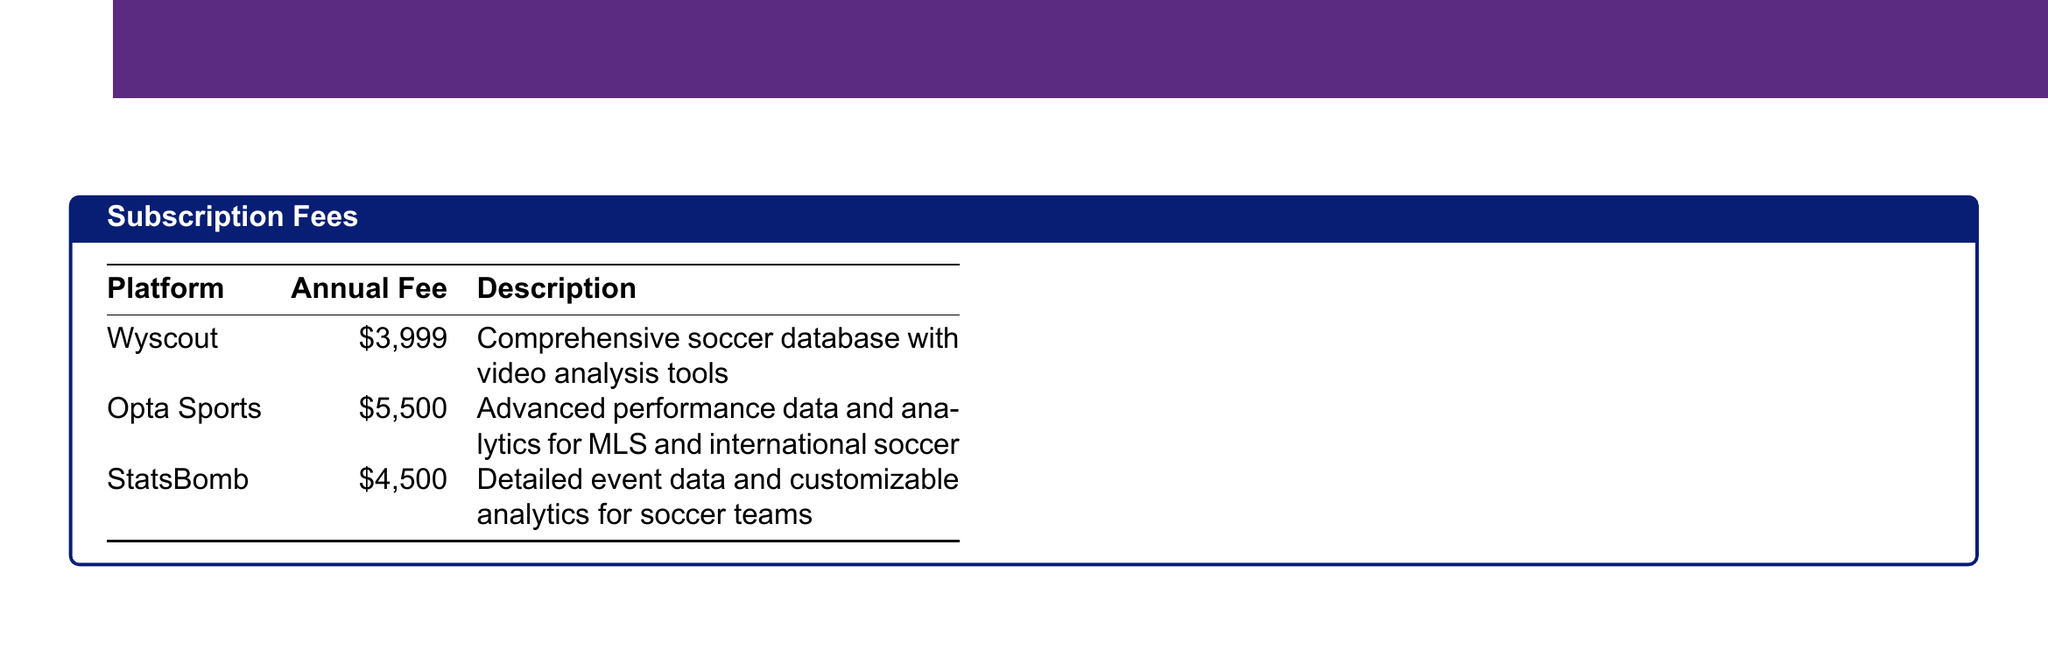What is the annual fee for Wyscout? The annual fee for Wyscout is specified in the document as $3,999.
Answer: $3,999 What is the total cost for subscription fees? The total cost for subscription fees is clearly laid out in the document as $13,999.
Answer: $13,999 How much does the online course cost? The document lists the cost of the online course as $499.
Answer: $499 What is the fee for custom Rapids reports? The fee for custom Rapids reports is mentioned as $250 per month in the document.
Answer: $250/month What platform has the highest annual fee? By comparing the annual fees listed, Opta Sports has the highest fee at $5,500.
Answer: Opta Sports What is the total annual budget? The document includes a summary stating the total annual budget is $23,298.
Answer: $23,298 How much does the fan opinion polling software cost annually? The document indicates that the fan opinion polling software costs $600 annually.
Answer: $600 What is the cost of the high-performance laptop? The cost of the high-performance laptop is stated in the document as $2,000.
Answer: $2,000 What is included in the additional costs? The additional costs include custom reports and MLS-wide trend analysis, amounting to approximately $6,000.
Answer: $6,000 (approx.) 